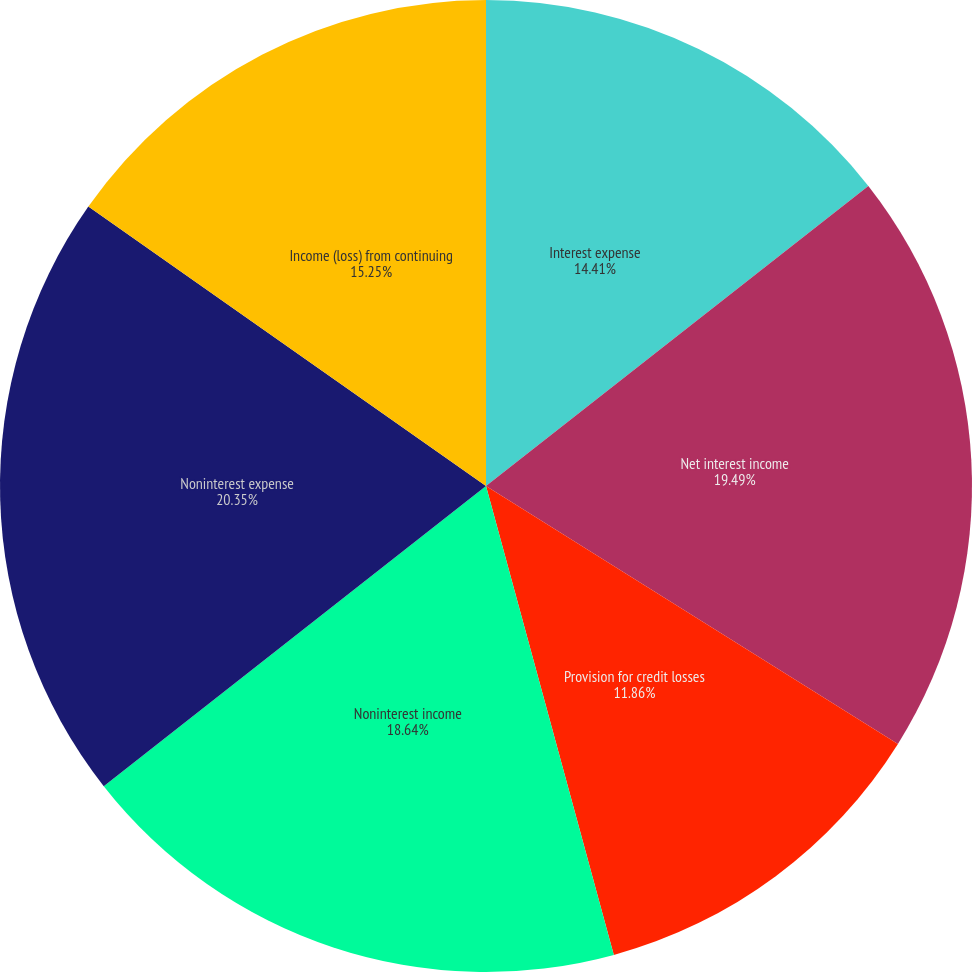Convert chart. <chart><loc_0><loc_0><loc_500><loc_500><pie_chart><fcel>Interest expense<fcel>Net interest income<fcel>Provision for credit losses<fcel>Noninterest income<fcel>Noninterest expense<fcel>Income (loss) from continuing<fcel>Net income (loss) attributable<nl><fcel>14.41%<fcel>19.49%<fcel>11.86%<fcel>18.64%<fcel>20.34%<fcel>15.25%<fcel>0.0%<nl></chart> 